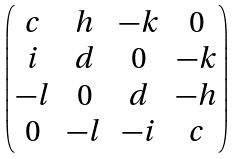Convert formula to latex. <formula><loc_0><loc_0><loc_500><loc_500>\begin{pmatrix} c & h & - k & 0 \\ i & d & 0 & - k \\ - l & 0 & d & - h \\ 0 & - l & - i & c \end{pmatrix}</formula> 